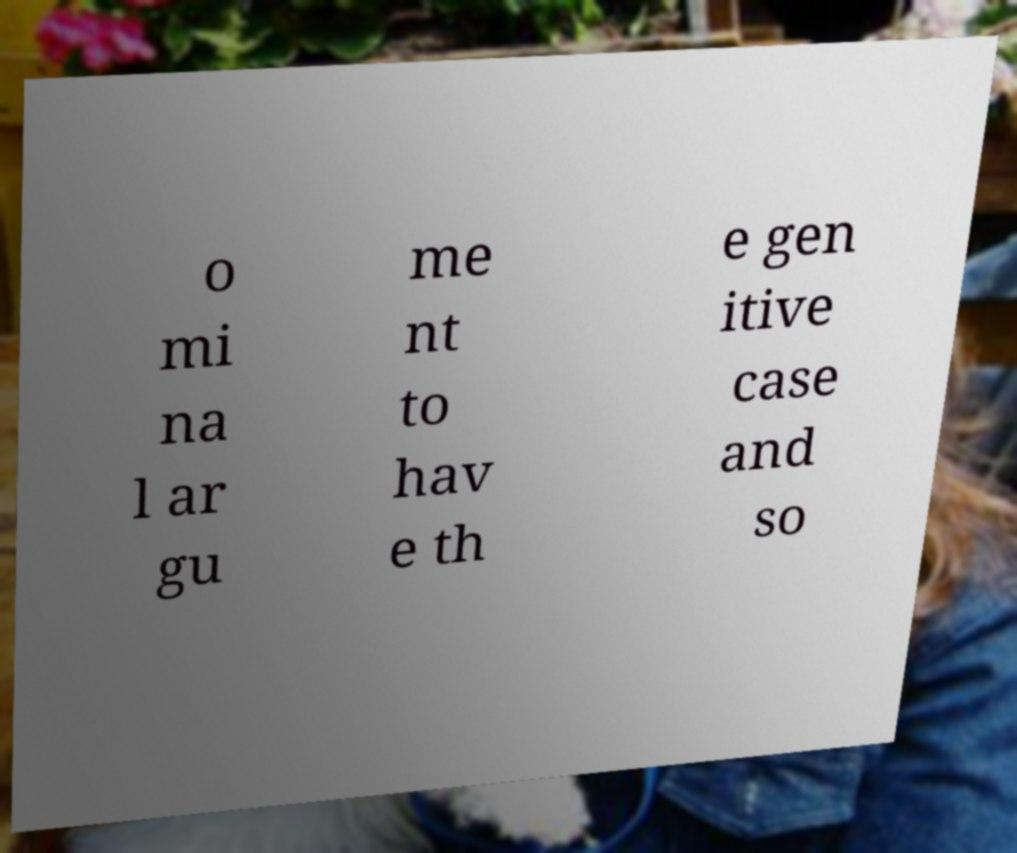For documentation purposes, I need the text within this image transcribed. Could you provide that? o mi na l ar gu me nt to hav e th e gen itive case and so 